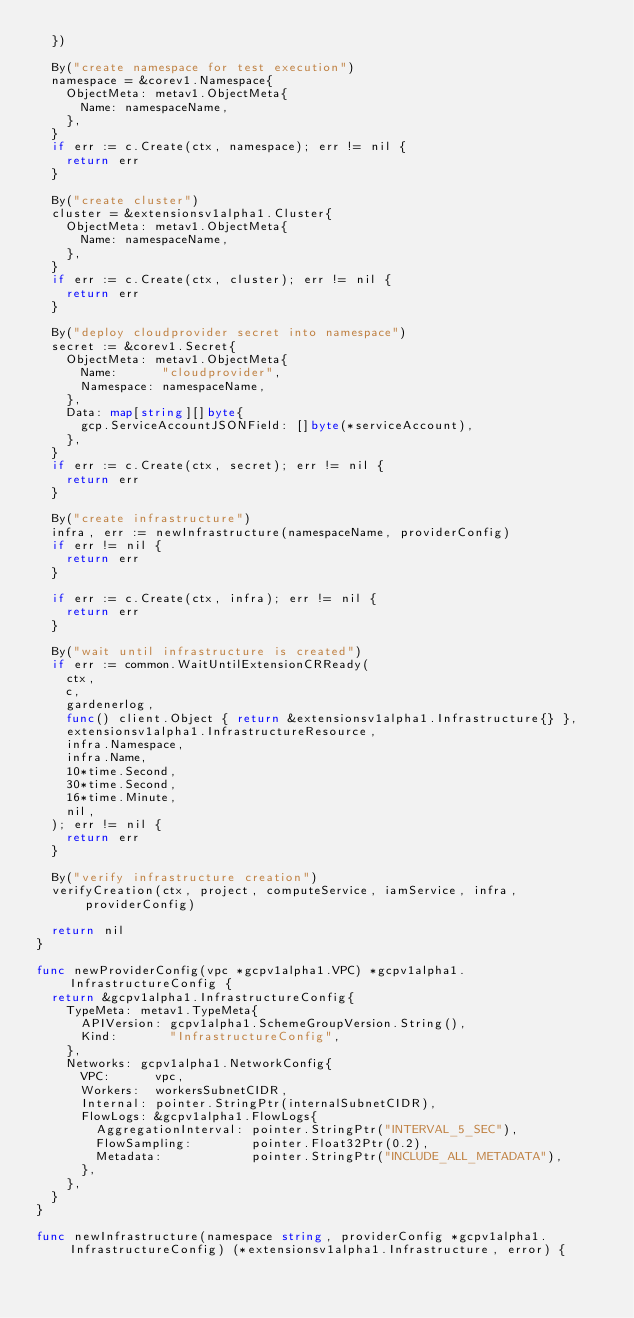Convert code to text. <code><loc_0><loc_0><loc_500><loc_500><_Go_>	})

	By("create namespace for test execution")
	namespace = &corev1.Namespace{
		ObjectMeta: metav1.ObjectMeta{
			Name: namespaceName,
		},
	}
	if err := c.Create(ctx, namespace); err != nil {
		return err
	}

	By("create cluster")
	cluster = &extensionsv1alpha1.Cluster{
		ObjectMeta: metav1.ObjectMeta{
			Name: namespaceName,
		},
	}
	if err := c.Create(ctx, cluster); err != nil {
		return err
	}

	By("deploy cloudprovider secret into namespace")
	secret := &corev1.Secret{
		ObjectMeta: metav1.ObjectMeta{
			Name:      "cloudprovider",
			Namespace: namespaceName,
		},
		Data: map[string][]byte{
			gcp.ServiceAccountJSONField: []byte(*serviceAccount),
		},
	}
	if err := c.Create(ctx, secret); err != nil {
		return err
	}

	By("create infrastructure")
	infra, err := newInfrastructure(namespaceName, providerConfig)
	if err != nil {
		return err
	}

	if err := c.Create(ctx, infra); err != nil {
		return err
	}

	By("wait until infrastructure is created")
	if err := common.WaitUntilExtensionCRReady(
		ctx,
		c,
		gardenerlog,
		func() client.Object { return &extensionsv1alpha1.Infrastructure{} },
		extensionsv1alpha1.InfrastructureResource,
		infra.Namespace,
		infra.Name,
		10*time.Second,
		30*time.Second,
		16*time.Minute,
		nil,
	); err != nil {
		return err
	}

	By("verify infrastructure creation")
	verifyCreation(ctx, project, computeService, iamService, infra, providerConfig)

	return nil
}

func newProviderConfig(vpc *gcpv1alpha1.VPC) *gcpv1alpha1.InfrastructureConfig {
	return &gcpv1alpha1.InfrastructureConfig{
		TypeMeta: metav1.TypeMeta{
			APIVersion: gcpv1alpha1.SchemeGroupVersion.String(),
			Kind:       "InfrastructureConfig",
		},
		Networks: gcpv1alpha1.NetworkConfig{
			VPC:      vpc,
			Workers:  workersSubnetCIDR,
			Internal: pointer.StringPtr(internalSubnetCIDR),
			FlowLogs: &gcpv1alpha1.FlowLogs{
				AggregationInterval: pointer.StringPtr("INTERVAL_5_SEC"),
				FlowSampling:        pointer.Float32Ptr(0.2),
				Metadata:            pointer.StringPtr("INCLUDE_ALL_METADATA"),
			},
		},
	}
}

func newInfrastructure(namespace string, providerConfig *gcpv1alpha1.InfrastructureConfig) (*extensionsv1alpha1.Infrastructure, error) {</code> 